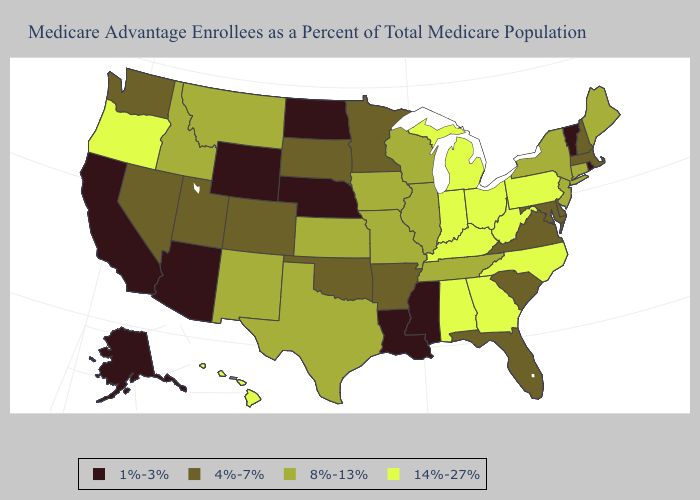What is the value of Connecticut?
Be succinct. 8%-13%. What is the highest value in states that border West Virginia?
Short answer required. 14%-27%. What is the value of North Dakota?
Write a very short answer. 1%-3%. Does Utah have the lowest value in the USA?
Keep it brief. No. Does Louisiana have the lowest value in the USA?
Concise answer only. Yes. What is the value of Tennessee?
Concise answer only. 8%-13%. What is the value of Wyoming?
Short answer required. 1%-3%. Does Wyoming have the lowest value in the USA?
Concise answer only. Yes. What is the value of Delaware?
Quick response, please. 4%-7%. Name the states that have a value in the range 8%-13%?
Give a very brief answer. Connecticut, Idaho, Illinois, Iowa, Kansas, Maine, Missouri, Montana, New Jersey, New Mexico, New York, Tennessee, Texas, Wisconsin. Name the states that have a value in the range 4%-7%?
Write a very short answer. Arkansas, Colorado, Delaware, Florida, Maryland, Massachusetts, Minnesota, Nevada, New Hampshire, Oklahoma, South Carolina, South Dakota, Utah, Virginia, Washington. Name the states that have a value in the range 14%-27%?
Short answer required. Alabama, Georgia, Hawaii, Indiana, Kentucky, Michigan, North Carolina, Ohio, Oregon, Pennsylvania, West Virginia. What is the highest value in states that border North Dakota?
Give a very brief answer. 8%-13%. What is the lowest value in states that border Utah?
Short answer required. 1%-3%. Among the states that border Oklahoma , does Arkansas have the highest value?
Concise answer only. No. 